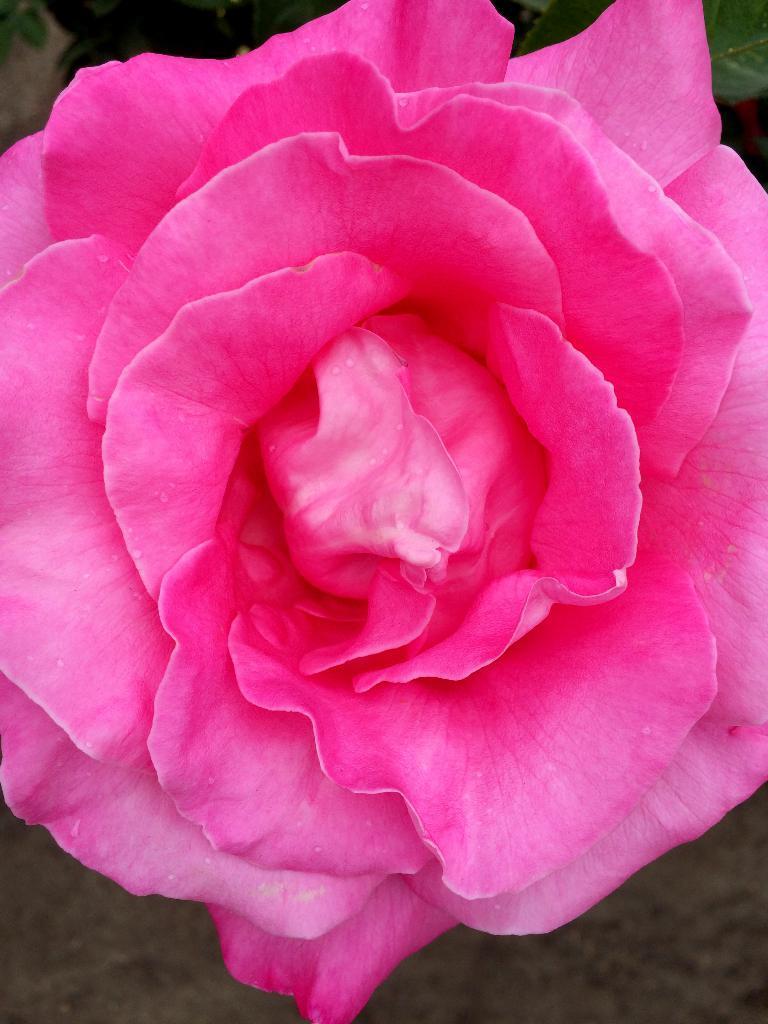Describe this image in one or two sentences. In this picture we can see a pink color rose flower, there is a blurry background, we can see petals of the flower. 